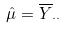<formula> <loc_0><loc_0><loc_500><loc_500>\hat { \mu } = \overline { Y } _ { \cdot \cdot }</formula> 